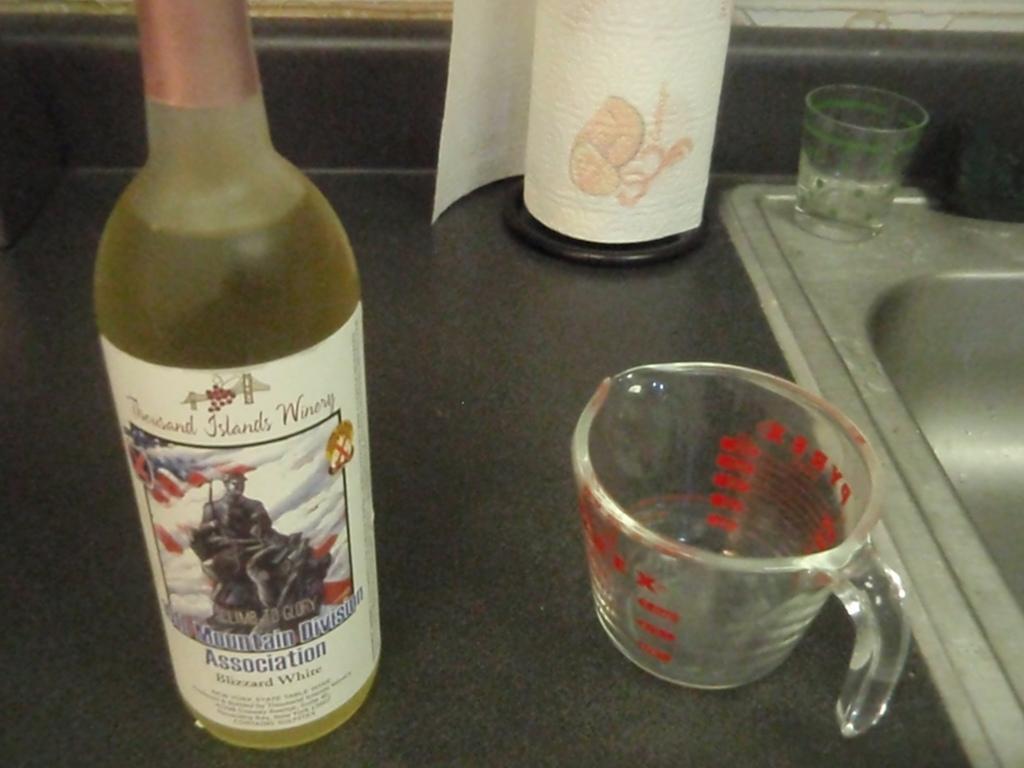Could you give a brief overview of what you see in this image? This is a picture, In a picture there is bottle on the bottle there is a sticker of a man and behind the bottle there is glass and the sink on the floor there is a tissue paper. 